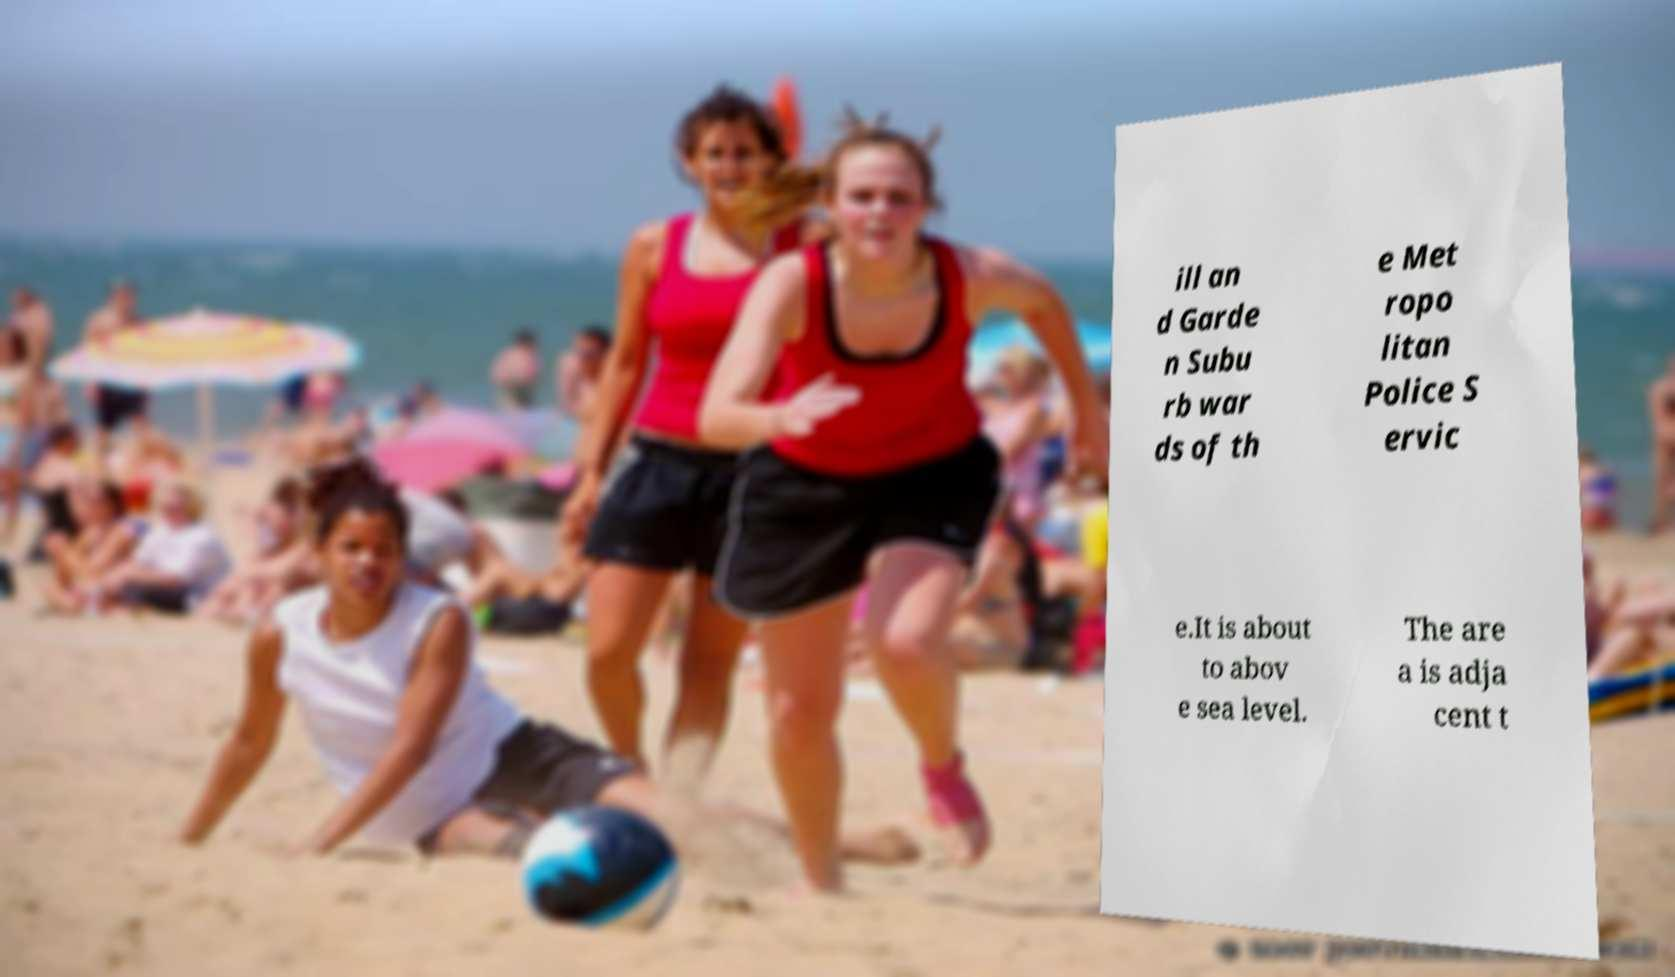Could you assist in decoding the text presented in this image and type it out clearly? ill an d Garde n Subu rb war ds of th e Met ropo litan Police S ervic e.It is about to abov e sea level. The are a is adja cent t 